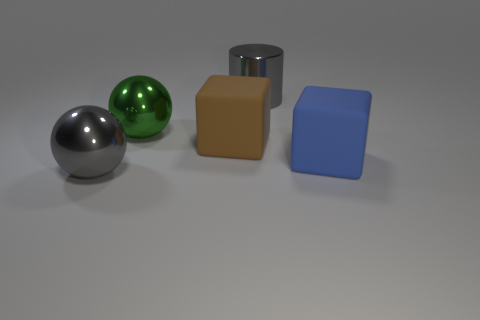Add 5 big gray balls. How many objects exist? 10 Subtract all spheres. How many objects are left? 3 Add 1 large metallic objects. How many large metallic objects are left? 4 Add 2 big gray things. How many big gray things exist? 4 Subtract 0 red cubes. How many objects are left? 5 Subtract all big gray balls. Subtract all yellow rubber blocks. How many objects are left? 4 